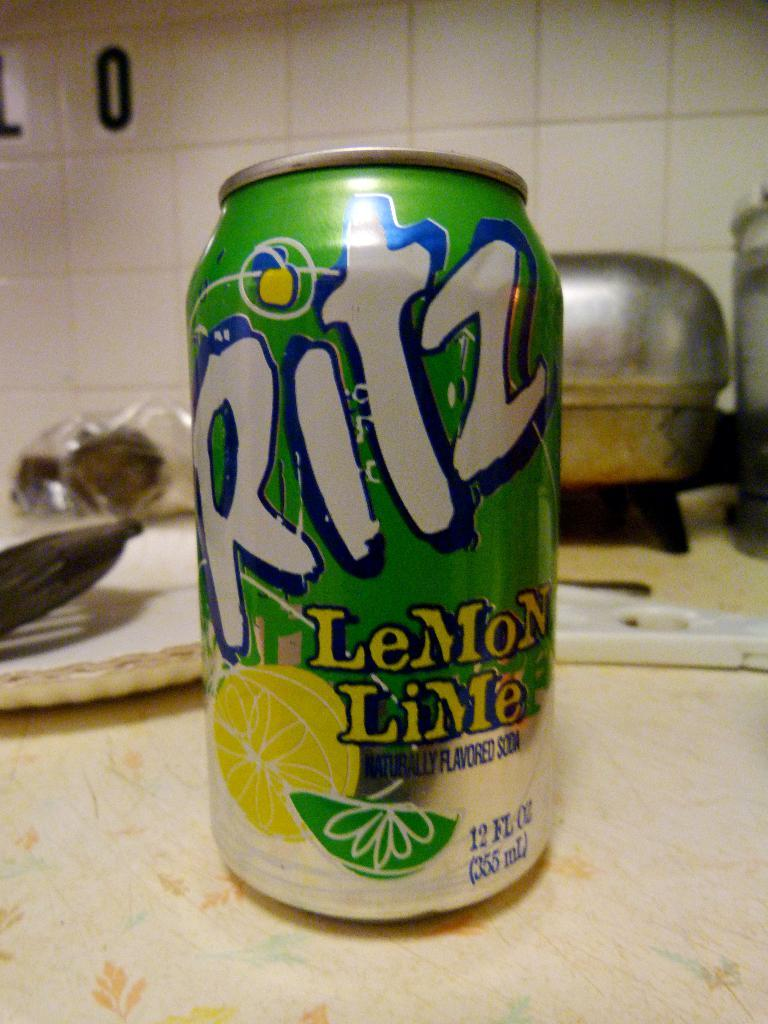<image>
Present a compact description of the photo's key features. A can of Ritz lemon lime soda sits on a kitchen counter. 